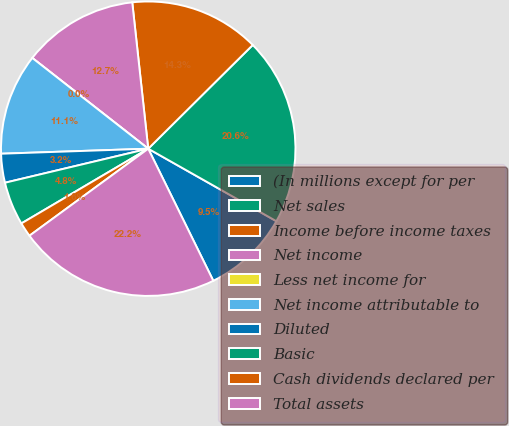Convert chart. <chart><loc_0><loc_0><loc_500><loc_500><pie_chart><fcel>(In millions except for per<fcel>Net sales<fcel>Income before income taxes<fcel>Net income<fcel>Less net income for<fcel>Net income attributable to<fcel>Diluted<fcel>Basic<fcel>Cash dividends declared per<fcel>Total assets<nl><fcel>9.52%<fcel>20.63%<fcel>14.29%<fcel>12.7%<fcel>0.0%<fcel>11.11%<fcel>3.17%<fcel>4.76%<fcel>1.59%<fcel>22.22%<nl></chart> 